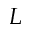Convert formula to latex. <formula><loc_0><loc_0><loc_500><loc_500>L</formula> 